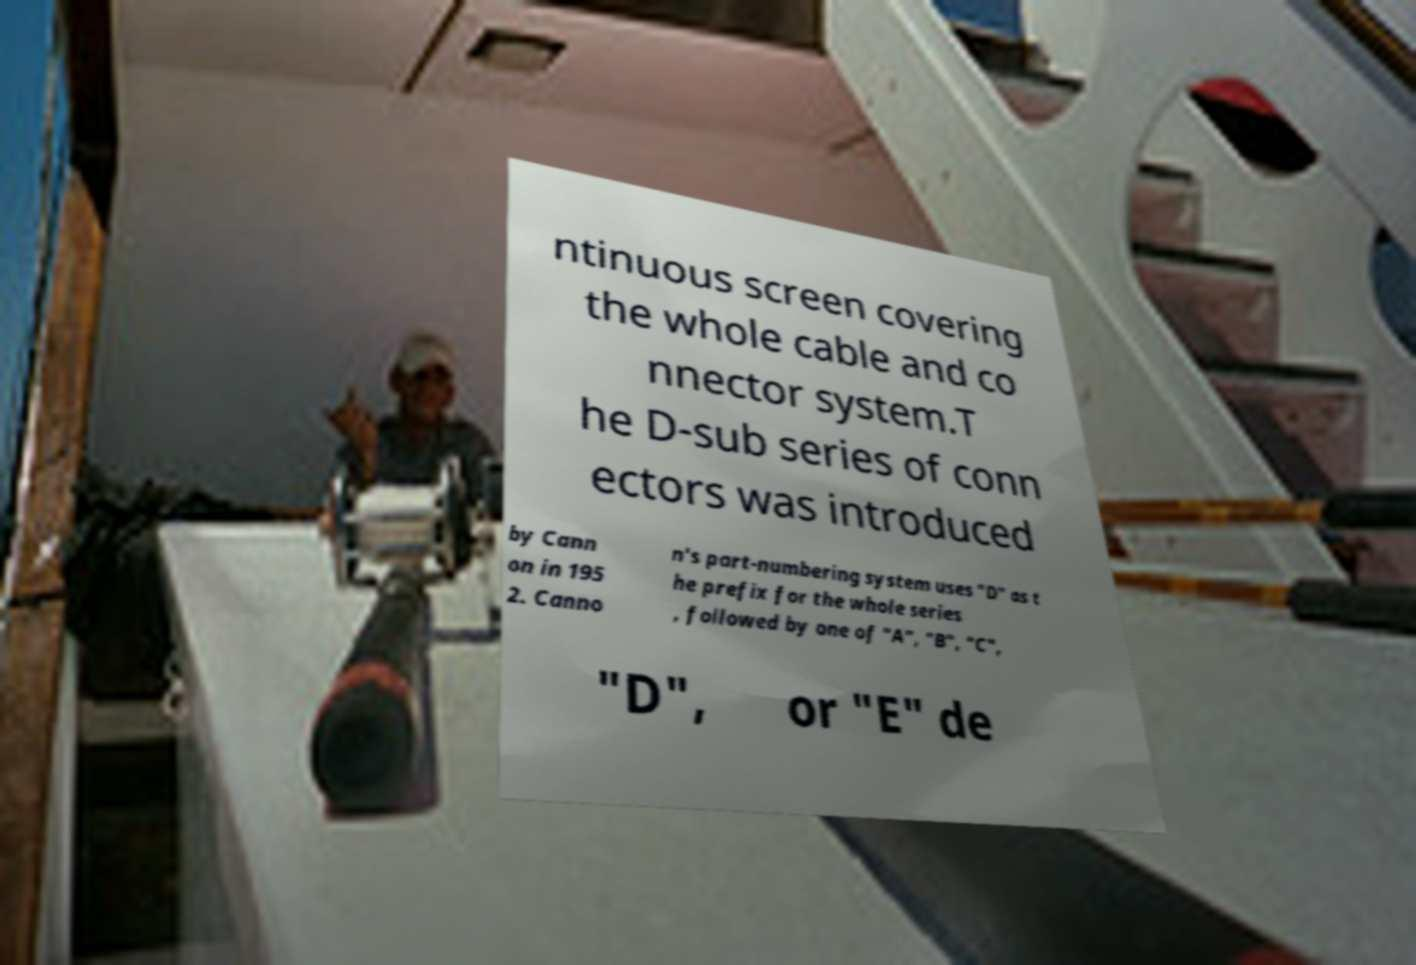Please read and relay the text visible in this image. What does it say? ntinuous screen covering the whole cable and co nnector system.T he D-sub series of conn ectors was introduced by Cann on in 195 2. Canno n's part-numbering system uses "D" as t he prefix for the whole series , followed by one of "A", "B", "C", "D", or "E" de 